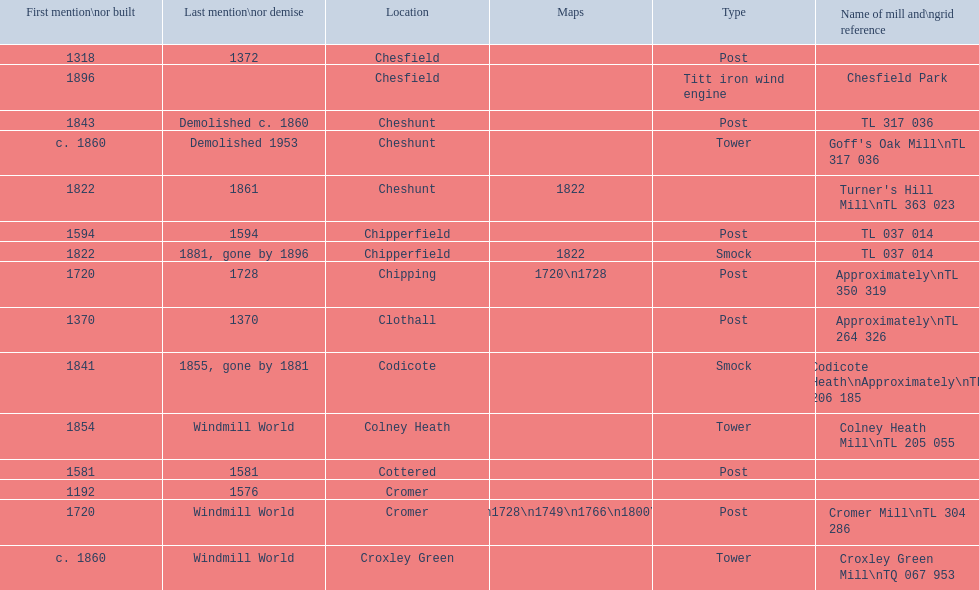What is the number of mills first mentioned or built in the 1800s? 8. 